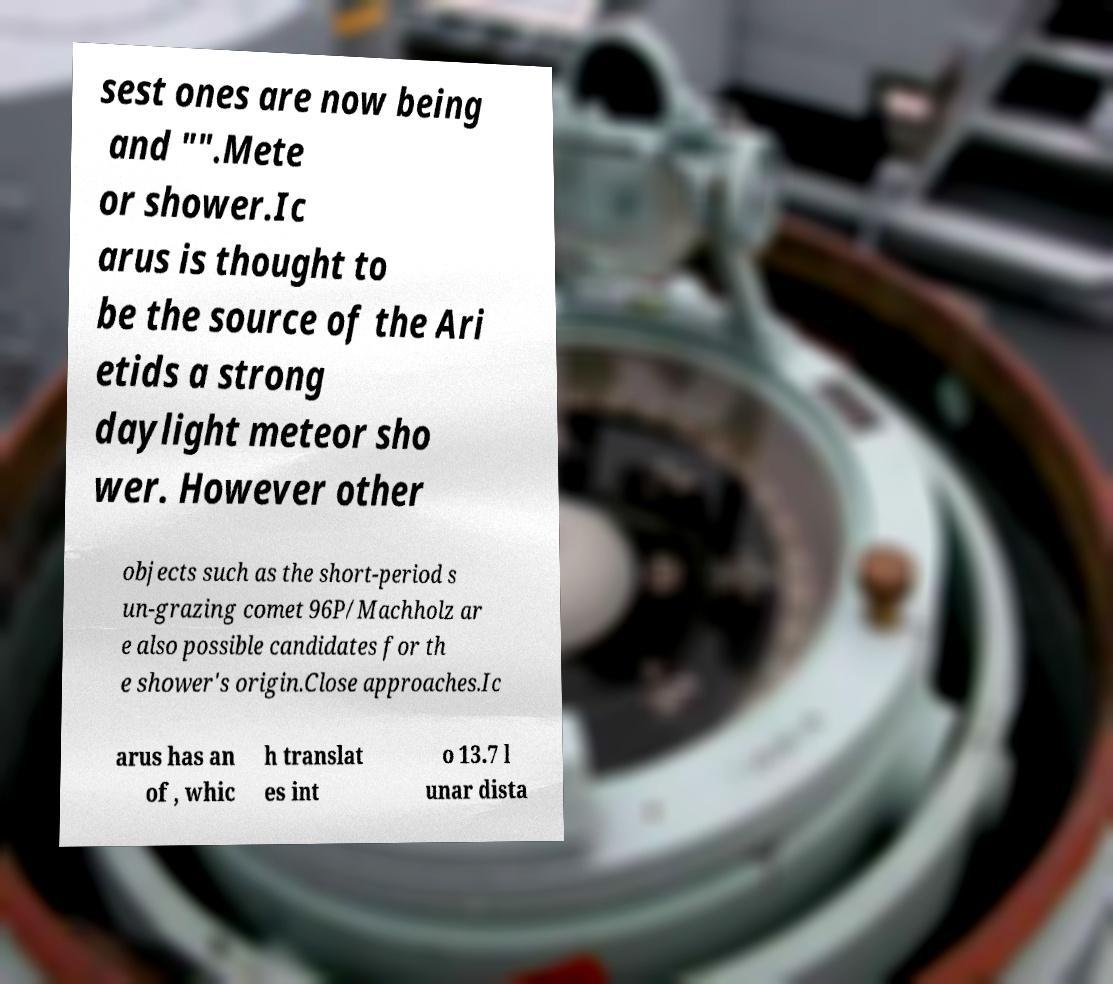Can you read and provide the text displayed in the image?This photo seems to have some interesting text. Can you extract and type it out for me? sest ones are now being and "".Mete or shower.Ic arus is thought to be the source of the Ari etids a strong daylight meteor sho wer. However other objects such as the short-period s un-grazing comet 96P/Machholz ar e also possible candidates for th e shower's origin.Close approaches.Ic arus has an of , whic h translat es int o 13.7 l unar dista 